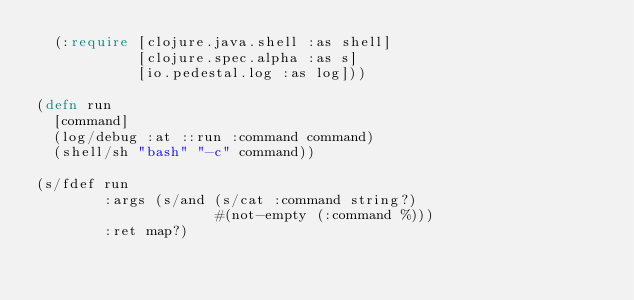Convert code to text. <code><loc_0><loc_0><loc_500><loc_500><_Clojure_>  (:require [clojure.java.shell :as shell]
            [clojure.spec.alpha :as s]
            [io.pedestal.log :as log]))

(defn run
  [command]
  (log/debug :at ::run :command command)
  (shell/sh "bash" "-c" command))

(s/fdef run
        :args (s/and (s/cat :command string?)
                     #(not-empty (:command %)))
        :ret map?)
</code> 